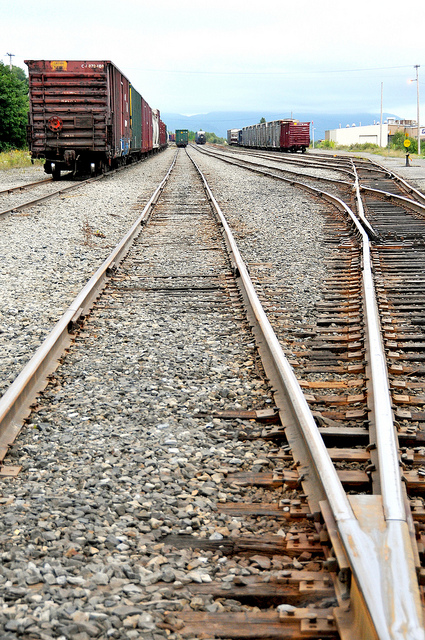<image>Why are there rocks in between the tracks? It is not known and ambiguous why there are rocks in between the tracks. They could be because to stop weeds, for train sparks, or for stability. Why are there rocks in between the tracks? I don't know why there are rocks in between the tracks. It could be to fill the space or to keep weeds from growing. 